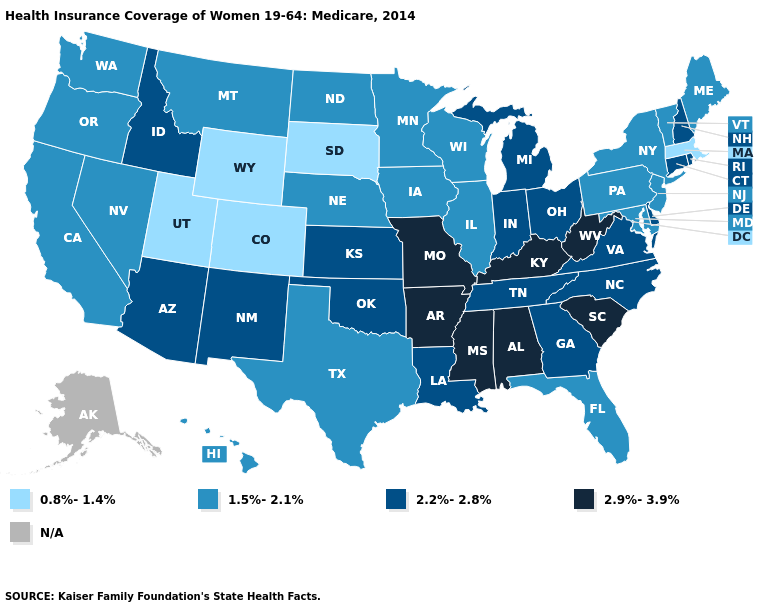What is the value of Idaho?
Concise answer only. 2.2%-2.8%. What is the value of Rhode Island?
Write a very short answer. 2.2%-2.8%. What is the value of Rhode Island?
Short answer required. 2.2%-2.8%. Name the states that have a value in the range 0.8%-1.4%?
Keep it brief. Colorado, Massachusetts, South Dakota, Utah, Wyoming. Does Mississippi have the highest value in the USA?
Quick response, please. Yes. How many symbols are there in the legend?
Concise answer only. 5. Among the states that border Colorado , does New Mexico have the highest value?
Short answer required. Yes. What is the value of Wyoming?
Concise answer only. 0.8%-1.4%. Among the states that border New Mexico , does Oklahoma have the lowest value?
Answer briefly. No. Name the states that have a value in the range 1.5%-2.1%?
Keep it brief. California, Florida, Hawaii, Illinois, Iowa, Maine, Maryland, Minnesota, Montana, Nebraska, Nevada, New Jersey, New York, North Dakota, Oregon, Pennsylvania, Texas, Vermont, Washington, Wisconsin. What is the value of Indiana?
Write a very short answer. 2.2%-2.8%. Among the states that border Arkansas , which have the highest value?
Give a very brief answer. Mississippi, Missouri. What is the highest value in states that border Oklahoma?
Give a very brief answer. 2.9%-3.9%. What is the highest value in the MidWest ?
Be succinct. 2.9%-3.9%. 